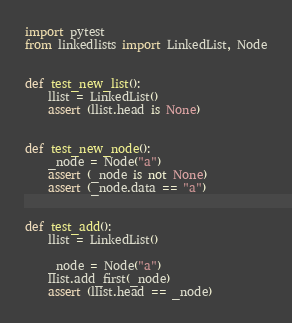<code> <loc_0><loc_0><loc_500><loc_500><_Python_>import pytest
from linkedlists import LinkedList, Node


def test_new_list():
    llist = LinkedList()
    assert (llist.head is None)


def test_new_node():
    _node = Node("a")
    assert (_node is not None)
    assert (_node.data == "a")


def test_add():
    llist = LinkedList()

    _node = Node("a")
    llist.add_first(_node)
    assert (llist.head == _node)
</code> 